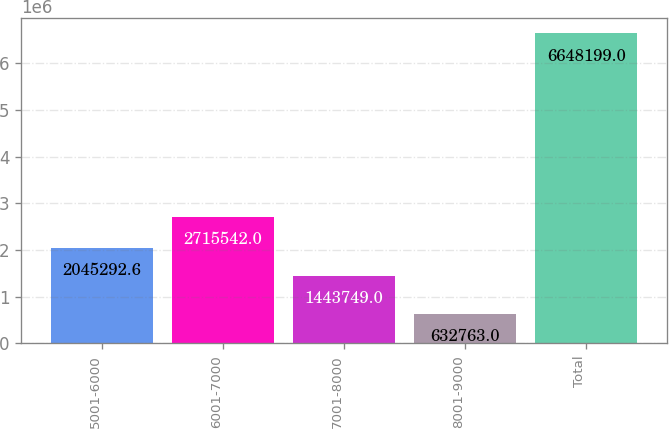Convert chart. <chart><loc_0><loc_0><loc_500><loc_500><bar_chart><fcel>5001-6000<fcel>6001-7000<fcel>7001-8000<fcel>8001-9000<fcel>Total<nl><fcel>2.04529e+06<fcel>2.71554e+06<fcel>1.44375e+06<fcel>632763<fcel>6.6482e+06<nl></chart> 